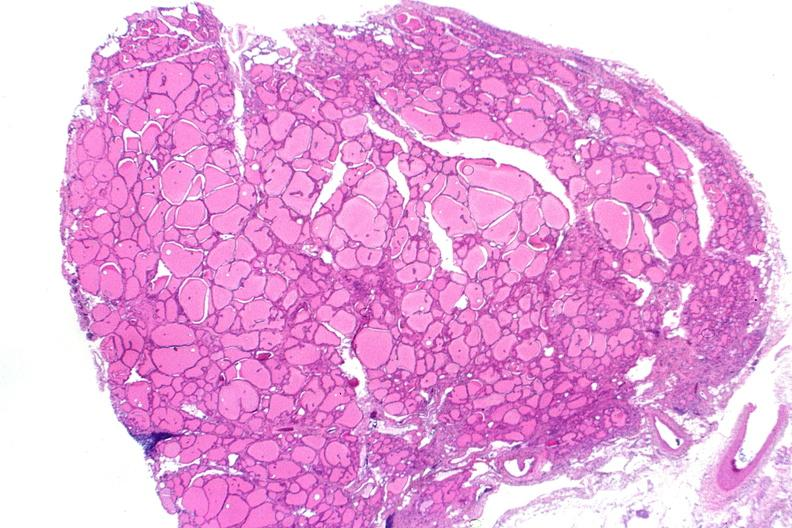what does this image show?
Answer the question using a single word or phrase. Thyroid 